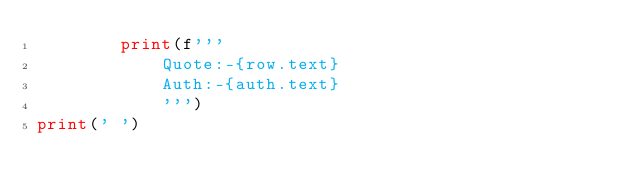Convert code to text. <code><loc_0><loc_0><loc_500><loc_500><_Python_>        print(f'''
            Quote:-{row.text}
            Auth:-{auth.text} 
            ''')
print(' ')

</code> 